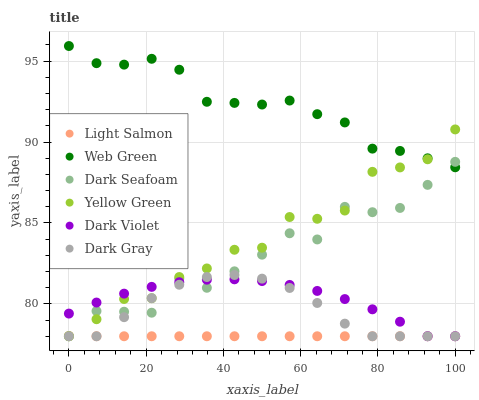Does Light Salmon have the minimum area under the curve?
Answer yes or no. Yes. Does Web Green have the maximum area under the curve?
Answer yes or no. Yes. Does Yellow Green have the minimum area under the curve?
Answer yes or no. No. Does Yellow Green have the maximum area under the curve?
Answer yes or no. No. Is Light Salmon the smoothest?
Answer yes or no. Yes. Is Dark Seafoam the roughest?
Answer yes or no. Yes. Is Yellow Green the smoothest?
Answer yes or no. No. Is Yellow Green the roughest?
Answer yes or no. No. Does Light Salmon have the lowest value?
Answer yes or no. Yes. Does Web Green have the lowest value?
Answer yes or no. No. Does Web Green have the highest value?
Answer yes or no. Yes. Does Yellow Green have the highest value?
Answer yes or no. No. Is Dark Violet less than Web Green?
Answer yes or no. Yes. Is Web Green greater than Dark Gray?
Answer yes or no. Yes. Does Dark Gray intersect Dark Violet?
Answer yes or no. Yes. Is Dark Gray less than Dark Violet?
Answer yes or no. No. Is Dark Gray greater than Dark Violet?
Answer yes or no. No. Does Dark Violet intersect Web Green?
Answer yes or no. No. 